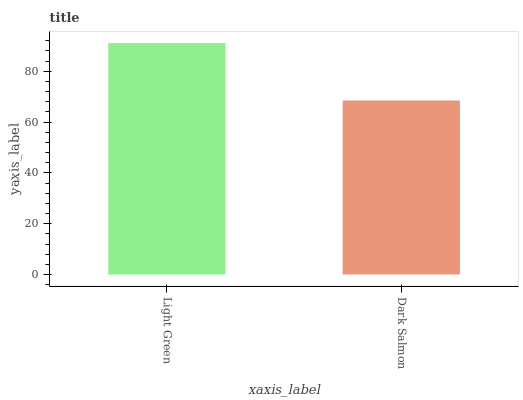Is Dark Salmon the minimum?
Answer yes or no. Yes. Is Light Green the maximum?
Answer yes or no. Yes. Is Dark Salmon the maximum?
Answer yes or no. No. Is Light Green greater than Dark Salmon?
Answer yes or no. Yes. Is Dark Salmon less than Light Green?
Answer yes or no. Yes. Is Dark Salmon greater than Light Green?
Answer yes or no. No. Is Light Green less than Dark Salmon?
Answer yes or no. No. Is Light Green the high median?
Answer yes or no. Yes. Is Dark Salmon the low median?
Answer yes or no. Yes. Is Dark Salmon the high median?
Answer yes or no. No. Is Light Green the low median?
Answer yes or no. No. 